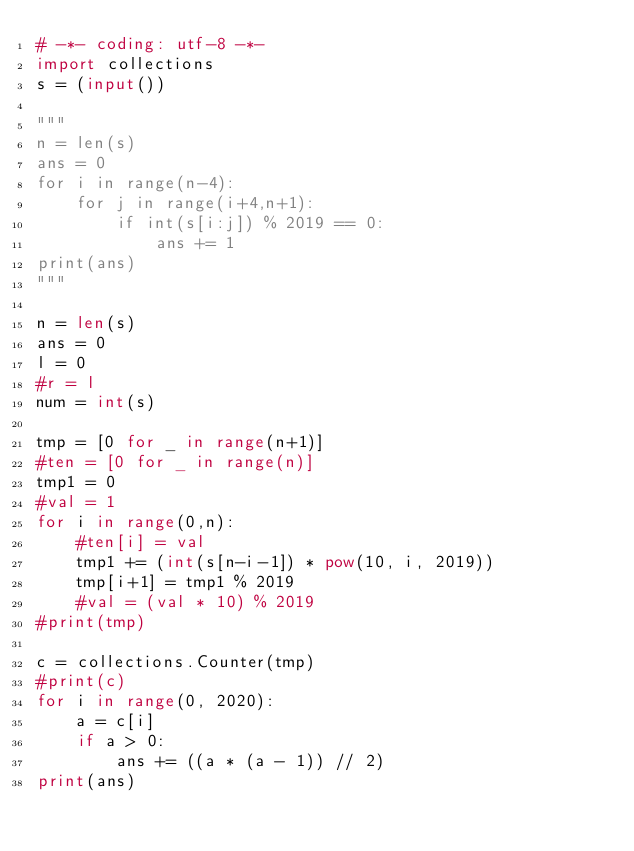Convert code to text. <code><loc_0><loc_0><loc_500><loc_500><_Python_># -*- coding: utf-8 -*-
import collections
s = (input())

"""
n = len(s)
ans = 0
for i in range(n-4):
    for j in range(i+4,n+1):
        if int(s[i:j]) % 2019 == 0:
            ans += 1
print(ans)
"""

n = len(s)
ans = 0
l = 0
#r = l
num = int(s)

tmp = [0 for _ in range(n+1)]
#ten = [0 for _ in range(n)]
tmp1 = 0
#val = 1
for i in range(0,n):
    #ten[i] = val
    tmp1 += (int(s[n-i-1]) * pow(10, i, 2019))
    tmp[i+1] = tmp1 % 2019
    #val = (val * 10) % 2019
#print(tmp)

c = collections.Counter(tmp)
#print(c)
for i in range(0, 2020):
    a = c[i]
    if a > 0:
        ans += ((a * (a - 1)) // 2)
print(ans)
</code> 